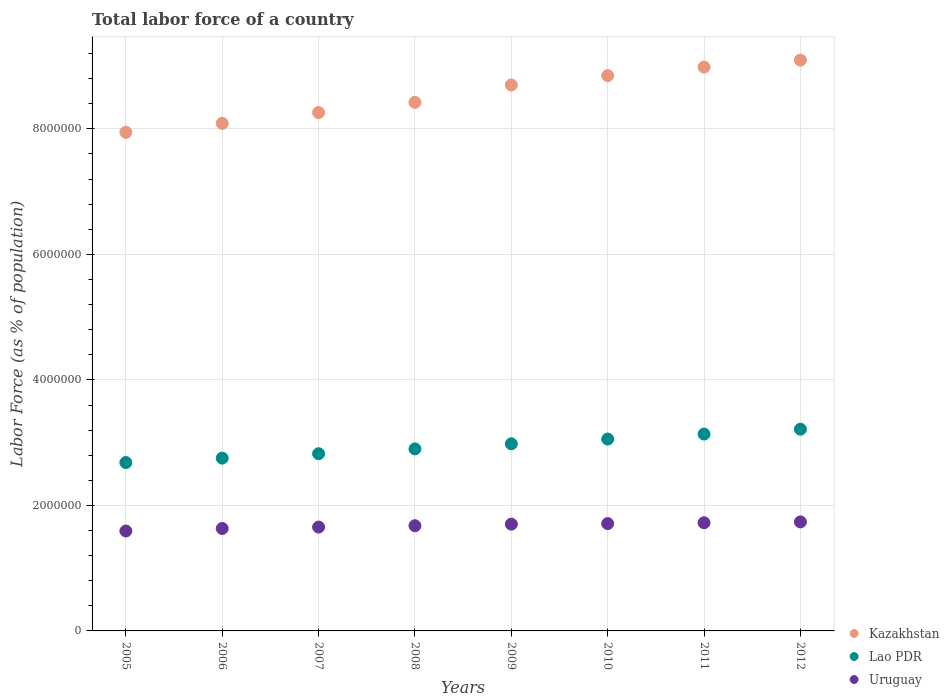Is the number of dotlines equal to the number of legend labels?
Give a very brief answer. Yes. What is the percentage of labor force in Lao PDR in 2012?
Give a very brief answer. 3.21e+06. Across all years, what is the maximum percentage of labor force in Lao PDR?
Your response must be concise. 3.21e+06. Across all years, what is the minimum percentage of labor force in Uruguay?
Your response must be concise. 1.59e+06. What is the total percentage of labor force in Kazakhstan in the graph?
Your response must be concise. 6.83e+07. What is the difference between the percentage of labor force in Lao PDR in 2007 and that in 2009?
Keep it short and to the point. -1.58e+05. What is the difference between the percentage of labor force in Uruguay in 2005 and the percentage of labor force in Lao PDR in 2009?
Your answer should be very brief. -1.39e+06. What is the average percentage of labor force in Lao PDR per year?
Provide a short and direct response. 2.94e+06. In the year 2008, what is the difference between the percentage of labor force in Kazakhstan and percentage of labor force in Uruguay?
Your response must be concise. 6.75e+06. What is the ratio of the percentage of labor force in Lao PDR in 2008 to that in 2010?
Your response must be concise. 0.95. Is the percentage of labor force in Uruguay in 2007 less than that in 2012?
Provide a short and direct response. Yes. What is the difference between the highest and the second highest percentage of labor force in Uruguay?
Provide a succinct answer. 1.34e+04. What is the difference between the highest and the lowest percentage of labor force in Lao PDR?
Give a very brief answer. 5.31e+05. In how many years, is the percentage of labor force in Kazakhstan greater than the average percentage of labor force in Kazakhstan taken over all years?
Your response must be concise. 4. Is it the case that in every year, the sum of the percentage of labor force in Kazakhstan and percentage of labor force in Uruguay  is greater than the percentage of labor force in Lao PDR?
Provide a short and direct response. Yes. Is the percentage of labor force in Kazakhstan strictly less than the percentage of labor force in Lao PDR over the years?
Provide a succinct answer. No. How many years are there in the graph?
Keep it short and to the point. 8. Are the values on the major ticks of Y-axis written in scientific E-notation?
Provide a succinct answer. No. What is the title of the graph?
Your answer should be very brief. Total labor force of a country. Does "Guinea-Bissau" appear as one of the legend labels in the graph?
Your answer should be compact. No. What is the label or title of the Y-axis?
Your response must be concise. Labor Force (as % of population). What is the Labor Force (as % of population) of Kazakhstan in 2005?
Give a very brief answer. 7.95e+06. What is the Labor Force (as % of population) in Lao PDR in 2005?
Keep it short and to the point. 2.68e+06. What is the Labor Force (as % of population) in Uruguay in 2005?
Your response must be concise. 1.59e+06. What is the Labor Force (as % of population) in Kazakhstan in 2006?
Offer a terse response. 8.09e+06. What is the Labor Force (as % of population) of Lao PDR in 2006?
Keep it short and to the point. 2.75e+06. What is the Labor Force (as % of population) of Uruguay in 2006?
Your answer should be very brief. 1.63e+06. What is the Labor Force (as % of population) of Kazakhstan in 2007?
Offer a very short reply. 8.26e+06. What is the Labor Force (as % of population) of Lao PDR in 2007?
Your response must be concise. 2.82e+06. What is the Labor Force (as % of population) of Uruguay in 2007?
Make the answer very short. 1.65e+06. What is the Labor Force (as % of population) of Kazakhstan in 2008?
Provide a succinct answer. 8.42e+06. What is the Labor Force (as % of population) in Lao PDR in 2008?
Your response must be concise. 2.90e+06. What is the Labor Force (as % of population) in Uruguay in 2008?
Provide a succinct answer. 1.68e+06. What is the Labor Force (as % of population) of Kazakhstan in 2009?
Your response must be concise. 8.70e+06. What is the Labor Force (as % of population) in Lao PDR in 2009?
Your answer should be compact. 2.98e+06. What is the Labor Force (as % of population) of Uruguay in 2009?
Provide a succinct answer. 1.70e+06. What is the Labor Force (as % of population) in Kazakhstan in 2010?
Offer a very short reply. 8.85e+06. What is the Labor Force (as % of population) in Lao PDR in 2010?
Make the answer very short. 3.06e+06. What is the Labor Force (as % of population) of Uruguay in 2010?
Your answer should be compact. 1.71e+06. What is the Labor Force (as % of population) in Kazakhstan in 2011?
Offer a terse response. 8.98e+06. What is the Labor Force (as % of population) of Lao PDR in 2011?
Your answer should be very brief. 3.14e+06. What is the Labor Force (as % of population) of Uruguay in 2011?
Provide a short and direct response. 1.72e+06. What is the Labor Force (as % of population) in Kazakhstan in 2012?
Your response must be concise. 9.10e+06. What is the Labor Force (as % of population) of Lao PDR in 2012?
Provide a short and direct response. 3.21e+06. What is the Labor Force (as % of population) in Uruguay in 2012?
Provide a short and direct response. 1.74e+06. Across all years, what is the maximum Labor Force (as % of population) in Kazakhstan?
Your response must be concise. 9.10e+06. Across all years, what is the maximum Labor Force (as % of population) of Lao PDR?
Your answer should be compact. 3.21e+06. Across all years, what is the maximum Labor Force (as % of population) of Uruguay?
Give a very brief answer. 1.74e+06. Across all years, what is the minimum Labor Force (as % of population) of Kazakhstan?
Offer a very short reply. 7.95e+06. Across all years, what is the minimum Labor Force (as % of population) in Lao PDR?
Your answer should be very brief. 2.68e+06. Across all years, what is the minimum Labor Force (as % of population) in Uruguay?
Offer a very short reply. 1.59e+06. What is the total Labor Force (as % of population) in Kazakhstan in the graph?
Your response must be concise. 6.83e+07. What is the total Labor Force (as % of population) of Lao PDR in the graph?
Your answer should be compact. 2.36e+07. What is the total Labor Force (as % of population) of Uruguay in the graph?
Keep it short and to the point. 1.34e+07. What is the difference between the Labor Force (as % of population) of Kazakhstan in 2005 and that in 2006?
Offer a very short reply. -1.43e+05. What is the difference between the Labor Force (as % of population) of Lao PDR in 2005 and that in 2006?
Provide a succinct answer. -7.01e+04. What is the difference between the Labor Force (as % of population) of Uruguay in 2005 and that in 2006?
Ensure brevity in your answer.  -4.05e+04. What is the difference between the Labor Force (as % of population) in Kazakhstan in 2005 and that in 2007?
Your answer should be compact. -3.15e+05. What is the difference between the Labor Force (as % of population) in Lao PDR in 2005 and that in 2007?
Make the answer very short. -1.41e+05. What is the difference between the Labor Force (as % of population) in Uruguay in 2005 and that in 2007?
Provide a succinct answer. -6.30e+04. What is the difference between the Labor Force (as % of population) of Kazakhstan in 2005 and that in 2008?
Your response must be concise. -4.77e+05. What is the difference between the Labor Force (as % of population) in Lao PDR in 2005 and that in 2008?
Keep it short and to the point. -2.17e+05. What is the difference between the Labor Force (as % of population) of Uruguay in 2005 and that in 2008?
Your answer should be very brief. -8.47e+04. What is the difference between the Labor Force (as % of population) of Kazakhstan in 2005 and that in 2009?
Provide a short and direct response. -7.55e+05. What is the difference between the Labor Force (as % of population) of Lao PDR in 2005 and that in 2009?
Make the answer very short. -2.99e+05. What is the difference between the Labor Force (as % of population) of Uruguay in 2005 and that in 2009?
Your answer should be very brief. -1.09e+05. What is the difference between the Labor Force (as % of population) of Kazakhstan in 2005 and that in 2010?
Offer a terse response. -9.03e+05. What is the difference between the Labor Force (as % of population) in Lao PDR in 2005 and that in 2010?
Offer a terse response. -3.75e+05. What is the difference between the Labor Force (as % of population) in Uruguay in 2005 and that in 2010?
Provide a succinct answer. -1.18e+05. What is the difference between the Labor Force (as % of population) of Kazakhstan in 2005 and that in 2011?
Keep it short and to the point. -1.04e+06. What is the difference between the Labor Force (as % of population) in Lao PDR in 2005 and that in 2011?
Provide a short and direct response. -4.54e+05. What is the difference between the Labor Force (as % of population) of Uruguay in 2005 and that in 2011?
Keep it short and to the point. -1.32e+05. What is the difference between the Labor Force (as % of population) of Kazakhstan in 2005 and that in 2012?
Your response must be concise. -1.15e+06. What is the difference between the Labor Force (as % of population) of Lao PDR in 2005 and that in 2012?
Your answer should be very brief. -5.31e+05. What is the difference between the Labor Force (as % of population) in Uruguay in 2005 and that in 2012?
Your response must be concise. -1.45e+05. What is the difference between the Labor Force (as % of population) of Kazakhstan in 2006 and that in 2007?
Provide a short and direct response. -1.71e+05. What is the difference between the Labor Force (as % of population) of Lao PDR in 2006 and that in 2007?
Your response must be concise. -7.05e+04. What is the difference between the Labor Force (as % of population) in Uruguay in 2006 and that in 2007?
Offer a terse response. -2.25e+04. What is the difference between the Labor Force (as % of population) of Kazakhstan in 2006 and that in 2008?
Your answer should be compact. -3.34e+05. What is the difference between the Labor Force (as % of population) in Lao PDR in 2006 and that in 2008?
Keep it short and to the point. -1.47e+05. What is the difference between the Labor Force (as % of population) in Uruguay in 2006 and that in 2008?
Provide a succinct answer. -4.42e+04. What is the difference between the Labor Force (as % of population) in Kazakhstan in 2006 and that in 2009?
Keep it short and to the point. -6.11e+05. What is the difference between the Labor Force (as % of population) in Lao PDR in 2006 and that in 2009?
Provide a succinct answer. -2.28e+05. What is the difference between the Labor Force (as % of population) in Uruguay in 2006 and that in 2009?
Offer a terse response. -6.90e+04. What is the difference between the Labor Force (as % of population) in Kazakhstan in 2006 and that in 2010?
Give a very brief answer. -7.60e+05. What is the difference between the Labor Force (as % of population) in Lao PDR in 2006 and that in 2010?
Keep it short and to the point. -3.05e+05. What is the difference between the Labor Force (as % of population) in Uruguay in 2006 and that in 2010?
Provide a short and direct response. -7.79e+04. What is the difference between the Labor Force (as % of population) in Kazakhstan in 2006 and that in 2011?
Your response must be concise. -8.96e+05. What is the difference between the Labor Force (as % of population) in Lao PDR in 2006 and that in 2011?
Offer a terse response. -3.84e+05. What is the difference between the Labor Force (as % of population) of Uruguay in 2006 and that in 2011?
Provide a succinct answer. -9.13e+04. What is the difference between the Labor Force (as % of population) of Kazakhstan in 2006 and that in 2012?
Offer a very short reply. -1.01e+06. What is the difference between the Labor Force (as % of population) of Lao PDR in 2006 and that in 2012?
Your answer should be very brief. -4.61e+05. What is the difference between the Labor Force (as % of population) in Uruguay in 2006 and that in 2012?
Your answer should be compact. -1.05e+05. What is the difference between the Labor Force (as % of population) of Kazakhstan in 2007 and that in 2008?
Your answer should be compact. -1.63e+05. What is the difference between the Labor Force (as % of population) in Lao PDR in 2007 and that in 2008?
Your answer should be very brief. -7.68e+04. What is the difference between the Labor Force (as % of population) in Uruguay in 2007 and that in 2008?
Offer a terse response. -2.17e+04. What is the difference between the Labor Force (as % of population) in Kazakhstan in 2007 and that in 2009?
Your answer should be very brief. -4.40e+05. What is the difference between the Labor Force (as % of population) in Lao PDR in 2007 and that in 2009?
Ensure brevity in your answer.  -1.58e+05. What is the difference between the Labor Force (as % of population) of Uruguay in 2007 and that in 2009?
Provide a short and direct response. -4.65e+04. What is the difference between the Labor Force (as % of population) in Kazakhstan in 2007 and that in 2010?
Ensure brevity in your answer.  -5.88e+05. What is the difference between the Labor Force (as % of population) of Lao PDR in 2007 and that in 2010?
Make the answer very short. -2.34e+05. What is the difference between the Labor Force (as % of population) of Uruguay in 2007 and that in 2010?
Offer a very short reply. -5.54e+04. What is the difference between the Labor Force (as % of population) in Kazakhstan in 2007 and that in 2011?
Provide a succinct answer. -7.25e+05. What is the difference between the Labor Force (as % of population) of Lao PDR in 2007 and that in 2011?
Keep it short and to the point. -3.13e+05. What is the difference between the Labor Force (as % of population) of Uruguay in 2007 and that in 2011?
Your response must be concise. -6.88e+04. What is the difference between the Labor Force (as % of population) of Kazakhstan in 2007 and that in 2012?
Offer a terse response. -8.36e+05. What is the difference between the Labor Force (as % of population) in Lao PDR in 2007 and that in 2012?
Your answer should be compact. -3.91e+05. What is the difference between the Labor Force (as % of population) of Uruguay in 2007 and that in 2012?
Your answer should be compact. -8.22e+04. What is the difference between the Labor Force (as % of population) of Kazakhstan in 2008 and that in 2009?
Offer a terse response. -2.78e+05. What is the difference between the Labor Force (as % of population) in Lao PDR in 2008 and that in 2009?
Offer a very short reply. -8.11e+04. What is the difference between the Labor Force (as % of population) in Uruguay in 2008 and that in 2009?
Ensure brevity in your answer.  -2.48e+04. What is the difference between the Labor Force (as % of population) of Kazakhstan in 2008 and that in 2010?
Your response must be concise. -4.26e+05. What is the difference between the Labor Force (as % of population) of Lao PDR in 2008 and that in 2010?
Give a very brief answer. -1.57e+05. What is the difference between the Labor Force (as % of population) in Uruguay in 2008 and that in 2010?
Give a very brief answer. -3.37e+04. What is the difference between the Labor Force (as % of population) in Kazakhstan in 2008 and that in 2011?
Your response must be concise. -5.62e+05. What is the difference between the Labor Force (as % of population) in Lao PDR in 2008 and that in 2011?
Keep it short and to the point. -2.36e+05. What is the difference between the Labor Force (as % of population) of Uruguay in 2008 and that in 2011?
Ensure brevity in your answer.  -4.71e+04. What is the difference between the Labor Force (as % of population) of Kazakhstan in 2008 and that in 2012?
Your answer should be compact. -6.73e+05. What is the difference between the Labor Force (as % of population) in Lao PDR in 2008 and that in 2012?
Keep it short and to the point. -3.14e+05. What is the difference between the Labor Force (as % of population) of Uruguay in 2008 and that in 2012?
Your answer should be compact. -6.05e+04. What is the difference between the Labor Force (as % of population) in Kazakhstan in 2009 and that in 2010?
Ensure brevity in your answer.  -1.48e+05. What is the difference between the Labor Force (as % of population) in Lao PDR in 2009 and that in 2010?
Provide a short and direct response. -7.61e+04. What is the difference between the Labor Force (as % of population) of Uruguay in 2009 and that in 2010?
Offer a very short reply. -8885. What is the difference between the Labor Force (as % of population) of Kazakhstan in 2009 and that in 2011?
Your answer should be very brief. -2.85e+05. What is the difference between the Labor Force (as % of population) in Lao PDR in 2009 and that in 2011?
Your answer should be compact. -1.55e+05. What is the difference between the Labor Force (as % of population) in Uruguay in 2009 and that in 2011?
Ensure brevity in your answer.  -2.23e+04. What is the difference between the Labor Force (as % of population) in Kazakhstan in 2009 and that in 2012?
Offer a very short reply. -3.96e+05. What is the difference between the Labor Force (as % of population) in Lao PDR in 2009 and that in 2012?
Give a very brief answer. -2.33e+05. What is the difference between the Labor Force (as % of population) in Uruguay in 2009 and that in 2012?
Ensure brevity in your answer.  -3.57e+04. What is the difference between the Labor Force (as % of population) of Kazakhstan in 2010 and that in 2011?
Your answer should be compact. -1.36e+05. What is the difference between the Labor Force (as % of population) of Lao PDR in 2010 and that in 2011?
Your answer should be very brief. -7.91e+04. What is the difference between the Labor Force (as % of population) in Uruguay in 2010 and that in 2011?
Give a very brief answer. -1.34e+04. What is the difference between the Labor Force (as % of population) in Kazakhstan in 2010 and that in 2012?
Provide a short and direct response. -2.47e+05. What is the difference between the Labor Force (as % of population) of Lao PDR in 2010 and that in 2012?
Provide a succinct answer. -1.57e+05. What is the difference between the Labor Force (as % of population) in Uruguay in 2010 and that in 2012?
Ensure brevity in your answer.  -2.68e+04. What is the difference between the Labor Force (as % of population) of Kazakhstan in 2011 and that in 2012?
Provide a succinct answer. -1.11e+05. What is the difference between the Labor Force (as % of population) in Lao PDR in 2011 and that in 2012?
Your answer should be very brief. -7.75e+04. What is the difference between the Labor Force (as % of population) in Uruguay in 2011 and that in 2012?
Make the answer very short. -1.34e+04. What is the difference between the Labor Force (as % of population) of Kazakhstan in 2005 and the Labor Force (as % of population) of Lao PDR in 2006?
Provide a succinct answer. 5.19e+06. What is the difference between the Labor Force (as % of population) of Kazakhstan in 2005 and the Labor Force (as % of population) of Uruguay in 2006?
Provide a short and direct response. 6.31e+06. What is the difference between the Labor Force (as % of population) of Lao PDR in 2005 and the Labor Force (as % of population) of Uruguay in 2006?
Offer a very short reply. 1.05e+06. What is the difference between the Labor Force (as % of population) in Kazakhstan in 2005 and the Labor Force (as % of population) in Lao PDR in 2007?
Offer a terse response. 5.12e+06. What is the difference between the Labor Force (as % of population) of Kazakhstan in 2005 and the Labor Force (as % of population) of Uruguay in 2007?
Your answer should be very brief. 6.29e+06. What is the difference between the Labor Force (as % of population) in Lao PDR in 2005 and the Labor Force (as % of population) in Uruguay in 2007?
Offer a very short reply. 1.03e+06. What is the difference between the Labor Force (as % of population) in Kazakhstan in 2005 and the Labor Force (as % of population) in Lao PDR in 2008?
Keep it short and to the point. 5.04e+06. What is the difference between the Labor Force (as % of population) of Kazakhstan in 2005 and the Labor Force (as % of population) of Uruguay in 2008?
Keep it short and to the point. 6.27e+06. What is the difference between the Labor Force (as % of population) in Lao PDR in 2005 and the Labor Force (as % of population) in Uruguay in 2008?
Ensure brevity in your answer.  1.01e+06. What is the difference between the Labor Force (as % of population) of Kazakhstan in 2005 and the Labor Force (as % of population) of Lao PDR in 2009?
Your answer should be compact. 4.96e+06. What is the difference between the Labor Force (as % of population) in Kazakhstan in 2005 and the Labor Force (as % of population) in Uruguay in 2009?
Keep it short and to the point. 6.24e+06. What is the difference between the Labor Force (as % of population) in Lao PDR in 2005 and the Labor Force (as % of population) in Uruguay in 2009?
Provide a succinct answer. 9.82e+05. What is the difference between the Labor Force (as % of population) in Kazakhstan in 2005 and the Labor Force (as % of population) in Lao PDR in 2010?
Offer a terse response. 4.89e+06. What is the difference between the Labor Force (as % of population) in Kazakhstan in 2005 and the Labor Force (as % of population) in Uruguay in 2010?
Your answer should be compact. 6.24e+06. What is the difference between the Labor Force (as % of population) in Lao PDR in 2005 and the Labor Force (as % of population) in Uruguay in 2010?
Provide a succinct answer. 9.73e+05. What is the difference between the Labor Force (as % of population) in Kazakhstan in 2005 and the Labor Force (as % of population) in Lao PDR in 2011?
Keep it short and to the point. 4.81e+06. What is the difference between the Labor Force (as % of population) in Kazakhstan in 2005 and the Labor Force (as % of population) in Uruguay in 2011?
Your answer should be very brief. 6.22e+06. What is the difference between the Labor Force (as % of population) in Lao PDR in 2005 and the Labor Force (as % of population) in Uruguay in 2011?
Keep it short and to the point. 9.59e+05. What is the difference between the Labor Force (as % of population) in Kazakhstan in 2005 and the Labor Force (as % of population) in Lao PDR in 2012?
Keep it short and to the point. 4.73e+06. What is the difference between the Labor Force (as % of population) in Kazakhstan in 2005 and the Labor Force (as % of population) in Uruguay in 2012?
Provide a short and direct response. 6.21e+06. What is the difference between the Labor Force (as % of population) of Lao PDR in 2005 and the Labor Force (as % of population) of Uruguay in 2012?
Offer a very short reply. 9.46e+05. What is the difference between the Labor Force (as % of population) in Kazakhstan in 2006 and the Labor Force (as % of population) in Lao PDR in 2007?
Keep it short and to the point. 5.26e+06. What is the difference between the Labor Force (as % of population) of Kazakhstan in 2006 and the Labor Force (as % of population) of Uruguay in 2007?
Your answer should be very brief. 6.43e+06. What is the difference between the Labor Force (as % of population) of Lao PDR in 2006 and the Labor Force (as % of population) of Uruguay in 2007?
Provide a short and direct response. 1.10e+06. What is the difference between the Labor Force (as % of population) in Kazakhstan in 2006 and the Labor Force (as % of population) in Lao PDR in 2008?
Provide a short and direct response. 5.19e+06. What is the difference between the Labor Force (as % of population) of Kazakhstan in 2006 and the Labor Force (as % of population) of Uruguay in 2008?
Offer a terse response. 6.41e+06. What is the difference between the Labor Force (as % of population) of Lao PDR in 2006 and the Labor Force (as % of population) of Uruguay in 2008?
Your answer should be compact. 1.08e+06. What is the difference between the Labor Force (as % of population) in Kazakhstan in 2006 and the Labor Force (as % of population) in Lao PDR in 2009?
Keep it short and to the point. 5.11e+06. What is the difference between the Labor Force (as % of population) of Kazakhstan in 2006 and the Labor Force (as % of population) of Uruguay in 2009?
Offer a very short reply. 6.39e+06. What is the difference between the Labor Force (as % of population) of Lao PDR in 2006 and the Labor Force (as % of population) of Uruguay in 2009?
Provide a succinct answer. 1.05e+06. What is the difference between the Labor Force (as % of population) in Kazakhstan in 2006 and the Labor Force (as % of population) in Lao PDR in 2010?
Make the answer very short. 5.03e+06. What is the difference between the Labor Force (as % of population) in Kazakhstan in 2006 and the Labor Force (as % of population) in Uruguay in 2010?
Keep it short and to the point. 6.38e+06. What is the difference between the Labor Force (as % of population) in Lao PDR in 2006 and the Labor Force (as % of population) in Uruguay in 2010?
Offer a terse response. 1.04e+06. What is the difference between the Labor Force (as % of population) of Kazakhstan in 2006 and the Labor Force (as % of population) of Lao PDR in 2011?
Offer a very short reply. 4.95e+06. What is the difference between the Labor Force (as % of population) of Kazakhstan in 2006 and the Labor Force (as % of population) of Uruguay in 2011?
Your response must be concise. 6.37e+06. What is the difference between the Labor Force (as % of population) of Lao PDR in 2006 and the Labor Force (as % of population) of Uruguay in 2011?
Your answer should be compact. 1.03e+06. What is the difference between the Labor Force (as % of population) of Kazakhstan in 2006 and the Labor Force (as % of population) of Lao PDR in 2012?
Offer a terse response. 4.87e+06. What is the difference between the Labor Force (as % of population) in Kazakhstan in 2006 and the Labor Force (as % of population) in Uruguay in 2012?
Provide a short and direct response. 6.35e+06. What is the difference between the Labor Force (as % of population) of Lao PDR in 2006 and the Labor Force (as % of population) of Uruguay in 2012?
Offer a very short reply. 1.02e+06. What is the difference between the Labor Force (as % of population) in Kazakhstan in 2007 and the Labor Force (as % of population) in Lao PDR in 2008?
Give a very brief answer. 5.36e+06. What is the difference between the Labor Force (as % of population) in Kazakhstan in 2007 and the Labor Force (as % of population) in Uruguay in 2008?
Your answer should be compact. 6.58e+06. What is the difference between the Labor Force (as % of population) of Lao PDR in 2007 and the Labor Force (as % of population) of Uruguay in 2008?
Your answer should be compact. 1.15e+06. What is the difference between the Labor Force (as % of population) in Kazakhstan in 2007 and the Labor Force (as % of population) in Lao PDR in 2009?
Your response must be concise. 5.28e+06. What is the difference between the Labor Force (as % of population) in Kazakhstan in 2007 and the Labor Force (as % of population) in Uruguay in 2009?
Offer a very short reply. 6.56e+06. What is the difference between the Labor Force (as % of population) in Lao PDR in 2007 and the Labor Force (as % of population) in Uruguay in 2009?
Make the answer very short. 1.12e+06. What is the difference between the Labor Force (as % of population) of Kazakhstan in 2007 and the Labor Force (as % of population) of Lao PDR in 2010?
Keep it short and to the point. 5.20e+06. What is the difference between the Labor Force (as % of population) of Kazakhstan in 2007 and the Labor Force (as % of population) of Uruguay in 2010?
Keep it short and to the point. 6.55e+06. What is the difference between the Labor Force (as % of population) of Lao PDR in 2007 and the Labor Force (as % of population) of Uruguay in 2010?
Provide a short and direct response. 1.11e+06. What is the difference between the Labor Force (as % of population) in Kazakhstan in 2007 and the Labor Force (as % of population) in Lao PDR in 2011?
Keep it short and to the point. 5.12e+06. What is the difference between the Labor Force (as % of population) in Kazakhstan in 2007 and the Labor Force (as % of population) in Uruguay in 2011?
Keep it short and to the point. 6.54e+06. What is the difference between the Labor Force (as % of population) in Lao PDR in 2007 and the Labor Force (as % of population) in Uruguay in 2011?
Ensure brevity in your answer.  1.10e+06. What is the difference between the Labor Force (as % of population) in Kazakhstan in 2007 and the Labor Force (as % of population) in Lao PDR in 2012?
Your response must be concise. 5.05e+06. What is the difference between the Labor Force (as % of population) of Kazakhstan in 2007 and the Labor Force (as % of population) of Uruguay in 2012?
Ensure brevity in your answer.  6.52e+06. What is the difference between the Labor Force (as % of population) in Lao PDR in 2007 and the Labor Force (as % of population) in Uruguay in 2012?
Make the answer very short. 1.09e+06. What is the difference between the Labor Force (as % of population) in Kazakhstan in 2008 and the Labor Force (as % of population) in Lao PDR in 2009?
Your response must be concise. 5.44e+06. What is the difference between the Labor Force (as % of population) of Kazakhstan in 2008 and the Labor Force (as % of population) of Uruguay in 2009?
Your answer should be very brief. 6.72e+06. What is the difference between the Labor Force (as % of population) of Lao PDR in 2008 and the Labor Force (as % of population) of Uruguay in 2009?
Offer a terse response. 1.20e+06. What is the difference between the Labor Force (as % of population) in Kazakhstan in 2008 and the Labor Force (as % of population) in Lao PDR in 2010?
Offer a very short reply. 5.36e+06. What is the difference between the Labor Force (as % of population) in Kazakhstan in 2008 and the Labor Force (as % of population) in Uruguay in 2010?
Keep it short and to the point. 6.71e+06. What is the difference between the Labor Force (as % of population) in Lao PDR in 2008 and the Labor Force (as % of population) in Uruguay in 2010?
Make the answer very short. 1.19e+06. What is the difference between the Labor Force (as % of population) of Kazakhstan in 2008 and the Labor Force (as % of population) of Lao PDR in 2011?
Your answer should be compact. 5.29e+06. What is the difference between the Labor Force (as % of population) of Kazakhstan in 2008 and the Labor Force (as % of population) of Uruguay in 2011?
Make the answer very short. 6.70e+06. What is the difference between the Labor Force (as % of population) in Lao PDR in 2008 and the Labor Force (as % of population) in Uruguay in 2011?
Your response must be concise. 1.18e+06. What is the difference between the Labor Force (as % of population) in Kazakhstan in 2008 and the Labor Force (as % of population) in Lao PDR in 2012?
Offer a very short reply. 5.21e+06. What is the difference between the Labor Force (as % of population) in Kazakhstan in 2008 and the Labor Force (as % of population) in Uruguay in 2012?
Offer a very short reply. 6.69e+06. What is the difference between the Labor Force (as % of population) of Lao PDR in 2008 and the Labor Force (as % of population) of Uruguay in 2012?
Give a very brief answer. 1.16e+06. What is the difference between the Labor Force (as % of population) of Kazakhstan in 2009 and the Labor Force (as % of population) of Lao PDR in 2010?
Your answer should be very brief. 5.64e+06. What is the difference between the Labor Force (as % of population) of Kazakhstan in 2009 and the Labor Force (as % of population) of Uruguay in 2010?
Provide a succinct answer. 6.99e+06. What is the difference between the Labor Force (as % of population) of Lao PDR in 2009 and the Labor Force (as % of population) of Uruguay in 2010?
Provide a short and direct response. 1.27e+06. What is the difference between the Labor Force (as % of population) of Kazakhstan in 2009 and the Labor Force (as % of population) of Lao PDR in 2011?
Your answer should be very brief. 5.56e+06. What is the difference between the Labor Force (as % of population) in Kazakhstan in 2009 and the Labor Force (as % of population) in Uruguay in 2011?
Make the answer very short. 6.98e+06. What is the difference between the Labor Force (as % of population) in Lao PDR in 2009 and the Labor Force (as % of population) in Uruguay in 2011?
Offer a very short reply. 1.26e+06. What is the difference between the Labor Force (as % of population) of Kazakhstan in 2009 and the Labor Force (as % of population) of Lao PDR in 2012?
Provide a succinct answer. 5.49e+06. What is the difference between the Labor Force (as % of population) of Kazakhstan in 2009 and the Labor Force (as % of population) of Uruguay in 2012?
Give a very brief answer. 6.96e+06. What is the difference between the Labor Force (as % of population) in Lao PDR in 2009 and the Labor Force (as % of population) in Uruguay in 2012?
Make the answer very short. 1.24e+06. What is the difference between the Labor Force (as % of population) of Kazakhstan in 2010 and the Labor Force (as % of population) of Lao PDR in 2011?
Ensure brevity in your answer.  5.71e+06. What is the difference between the Labor Force (as % of population) in Kazakhstan in 2010 and the Labor Force (as % of population) in Uruguay in 2011?
Ensure brevity in your answer.  7.12e+06. What is the difference between the Labor Force (as % of population) of Lao PDR in 2010 and the Labor Force (as % of population) of Uruguay in 2011?
Provide a succinct answer. 1.33e+06. What is the difference between the Labor Force (as % of population) of Kazakhstan in 2010 and the Labor Force (as % of population) of Lao PDR in 2012?
Offer a terse response. 5.63e+06. What is the difference between the Labor Force (as % of population) of Kazakhstan in 2010 and the Labor Force (as % of population) of Uruguay in 2012?
Your answer should be compact. 7.11e+06. What is the difference between the Labor Force (as % of population) of Lao PDR in 2010 and the Labor Force (as % of population) of Uruguay in 2012?
Ensure brevity in your answer.  1.32e+06. What is the difference between the Labor Force (as % of population) in Kazakhstan in 2011 and the Labor Force (as % of population) in Lao PDR in 2012?
Keep it short and to the point. 5.77e+06. What is the difference between the Labor Force (as % of population) of Kazakhstan in 2011 and the Labor Force (as % of population) of Uruguay in 2012?
Your answer should be compact. 7.25e+06. What is the difference between the Labor Force (as % of population) in Lao PDR in 2011 and the Labor Force (as % of population) in Uruguay in 2012?
Offer a terse response. 1.40e+06. What is the average Labor Force (as % of population) in Kazakhstan per year?
Provide a succinct answer. 8.54e+06. What is the average Labor Force (as % of population) in Lao PDR per year?
Ensure brevity in your answer.  2.94e+06. What is the average Labor Force (as % of population) in Uruguay per year?
Offer a very short reply. 1.68e+06. In the year 2005, what is the difference between the Labor Force (as % of population) of Kazakhstan and Labor Force (as % of population) of Lao PDR?
Give a very brief answer. 5.26e+06. In the year 2005, what is the difference between the Labor Force (as % of population) of Kazakhstan and Labor Force (as % of population) of Uruguay?
Ensure brevity in your answer.  6.35e+06. In the year 2005, what is the difference between the Labor Force (as % of population) of Lao PDR and Labor Force (as % of population) of Uruguay?
Give a very brief answer. 1.09e+06. In the year 2006, what is the difference between the Labor Force (as % of population) of Kazakhstan and Labor Force (as % of population) of Lao PDR?
Offer a terse response. 5.34e+06. In the year 2006, what is the difference between the Labor Force (as % of population) in Kazakhstan and Labor Force (as % of population) in Uruguay?
Keep it short and to the point. 6.46e+06. In the year 2006, what is the difference between the Labor Force (as % of population) of Lao PDR and Labor Force (as % of population) of Uruguay?
Make the answer very short. 1.12e+06. In the year 2007, what is the difference between the Labor Force (as % of population) of Kazakhstan and Labor Force (as % of population) of Lao PDR?
Your response must be concise. 5.44e+06. In the year 2007, what is the difference between the Labor Force (as % of population) in Kazakhstan and Labor Force (as % of population) in Uruguay?
Keep it short and to the point. 6.61e+06. In the year 2007, what is the difference between the Labor Force (as % of population) of Lao PDR and Labor Force (as % of population) of Uruguay?
Offer a very short reply. 1.17e+06. In the year 2008, what is the difference between the Labor Force (as % of population) of Kazakhstan and Labor Force (as % of population) of Lao PDR?
Ensure brevity in your answer.  5.52e+06. In the year 2008, what is the difference between the Labor Force (as % of population) of Kazakhstan and Labor Force (as % of population) of Uruguay?
Give a very brief answer. 6.75e+06. In the year 2008, what is the difference between the Labor Force (as % of population) of Lao PDR and Labor Force (as % of population) of Uruguay?
Make the answer very short. 1.22e+06. In the year 2009, what is the difference between the Labor Force (as % of population) of Kazakhstan and Labor Force (as % of population) of Lao PDR?
Offer a terse response. 5.72e+06. In the year 2009, what is the difference between the Labor Force (as % of population) in Kazakhstan and Labor Force (as % of population) in Uruguay?
Provide a succinct answer. 7.00e+06. In the year 2009, what is the difference between the Labor Force (as % of population) in Lao PDR and Labor Force (as % of population) in Uruguay?
Offer a very short reply. 1.28e+06. In the year 2010, what is the difference between the Labor Force (as % of population) of Kazakhstan and Labor Force (as % of population) of Lao PDR?
Your response must be concise. 5.79e+06. In the year 2010, what is the difference between the Labor Force (as % of population) of Kazakhstan and Labor Force (as % of population) of Uruguay?
Provide a succinct answer. 7.14e+06. In the year 2010, what is the difference between the Labor Force (as % of population) of Lao PDR and Labor Force (as % of population) of Uruguay?
Offer a terse response. 1.35e+06. In the year 2011, what is the difference between the Labor Force (as % of population) of Kazakhstan and Labor Force (as % of population) of Lao PDR?
Keep it short and to the point. 5.85e+06. In the year 2011, what is the difference between the Labor Force (as % of population) of Kazakhstan and Labor Force (as % of population) of Uruguay?
Offer a very short reply. 7.26e+06. In the year 2011, what is the difference between the Labor Force (as % of population) in Lao PDR and Labor Force (as % of population) in Uruguay?
Ensure brevity in your answer.  1.41e+06. In the year 2012, what is the difference between the Labor Force (as % of population) in Kazakhstan and Labor Force (as % of population) in Lao PDR?
Offer a very short reply. 5.88e+06. In the year 2012, what is the difference between the Labor Force (as % of population) in Kazakhstan and Labor Force (as % of population) in Uruguay?
Your answer should be very brief. 7.36e+06. In the year 2012, what is the difference between the Labor Force (as % of population) of Lao PDR and Labor Force (as % of population) of Uruguay?
Make the answer very short. 1.48e+06. What is the ratio of the Labor Force (as % of population) of Kazakhstan in 2005 to that in 2006?
Keep it short and to the point. 0.98. What is the ratio of the Labor Force (as % of population) in Lao PDR in 2005 to that in 2006?
Keep it short and to the point. 0.97. What is the ratio of the Labor Force (as % of population) in Uruguay in 2005 to that in 2006?
Make the answer very short. 0.98. What is the ratio of the Labor Force (as % of population) of Kazakhstan in 2005 to that in 2007?
Offer a very short reply. 0.96. What is the ratio of the Labor Force (as % of population) of Lao PDR in 2005 to that in 2007?
Offer a very short reply. 0.95. What is the ratio of the Labor Force (as % of population) of Uruguay in 2005 to that in 2007?
Ensure brevity in your answer.  0.96. What is the ratio of the Labor Force (as % of population) in Kazakhstan in 2005 to that in 2008?
Your answer should be very brief. 0.94. What is the ratio of the Labor Force (as % of population) of Lao PDR in 2005 to that in 2008?
Keep it short and to the point. 0.93. What is the ratio of the Labor Force (as % of population) of Uruguay in 2005 to that in 2008?
Make the answer very short. 0.95. What is the ratio of the Labor Force (as % of population) in Kazakhstan in 2005 to that in 2009?
Give a very brief answer. 0.91. What is the ratio of the Labor Force (as % of population) in Lao PDR in 2005 to that in 2009?
Give a very brief answer. 0.9. What is the ratio of the Labor Force (as % of population) of Uruguay in 2005 to that in 2009?
Provide a succinct answer. 0.94. What is the ratio of the Labor Force (as % of population) in Kazakhstan in 2005 to that in 2010?
Offer a very short reply. 0.9. What is the ratio of the Labor Force (as % of population) of Lao PDR in 2005 to that in 2010?
Ensure brevity in your answer.  0.88. What is the ratio of the Labor Force (as % of population) of Uruguay in 2005 to that in 2010?
Make the answer very short. 0.93. What is the ratio of the Labor Force (as % of population) of Kazakhstan in 2005 to that in 2011?
Your response must be concise. 0.88. What is the ratio of the Labor Force (as % of population) in Lao PDR in 2005 to that in 2011?
Your answer should be very brief. 0.86. What is the ratio of the Labor Force (as % of population) in Uruguay in 2005 to that in 2011?
Your answer should be compact. 0.92. What is the ratio of the Labor Force (as % of population) in Kazakhstan in 2005 to that in 2012?
Keep it short and to the point. 0.87. What is the ratio of the Labor Force (as % of population) of Lao PDR in 2005 to that in 2012?
Keep it short and to the point. 0.83. What is the ratio of the Labor Force (as % of population) of Uruguay in 2005 to that in 2012?
Make the answer very short. 0.92. What is the ratio of the Labor Force (as % of population) of Kazakhstan in 2006 to that in 2007?
Make the answer very short. 0.98. What is the ratio of the Labor Force (as % of population) of Lao PDR in 2006 to that in 2007?
Offer a terse response. 0.97. What is the ratio of the Labor Force (as % of population) in Uruguay in 2006 to that in 2007?
Offer a terse response. 0.99. What is the ratio of the Labor Force (as % of population) of Kazakhstan in 2006 to that in 2008?
Keep it short and to the point. 0.96. What is the ratio of the Labor Force (as % of population) of Lao PDR in 2006 to that in 2008?
Provide a short and direct response. 0.95. What is the ratio of the Labor Force (as % of population) in Uruguay in 2006 to that in 2008?
Offer a terse response. 0.97. What is the ratio of the Labor Force (as % of population) of Kazakhstan in 2006 to that in 2009?
Your answer should be very brief. 0.93. What is the ratio of the Labor Force (as % of population) of Lao PDR in 2006 to that in 2009?
Your response must be concise. 0.92. What is the ratio of the Labor Force (as % of population) of Uruguay in 2006 to that in 2009?
Offer a terse response. 0.96. What is the ratio of the Labor Force (as % of population) of Kazakhstan in 2006 to that in 2010?
Give a very brief answer. 0.91. What is the ratio of the Labor Force (as % of population) of Lao PDR in 2006 to that in 2010?
Keep it short and to the point. 0.9. What is the ratio of the Labor Force (as % of population) in Uruguay in 2006 to that in 2010?
Give a very brief answer. 0.95. What is the ratio of the Labor Force (as % of population) in Kazakhstan in 2006 to that in 2011?
Ensure brevity in your answer.  0.9. What is the ratio of the Labor Force (as % of population) of Lao PDR in 2006 to that in 2011?
Ensure brevity in your answer.  0.88. What is the ratio of the Labor Force (as % of population) of Uruguay in 2006 to that in 2011?
Provide a succinct answer. 0.95. What is the ratio of the Labor Force (as % of population) of Kazakhstan in 2006 to that in 2012?
Offer a terse response. 0.89. What is the ratio of the Labor Force (as % of population) in Lao PDR in 2006 to that in 2012?
Provide a short and direct response. 0.86. What is the ratio of the Labor Force (as % of population) of Uruguay in 2006 to that in 2012?
Ensure brevity in your answer.  0.94. What is the ratio of the Labor Force (as % of population) in Kazakhstan in 2007 to that in 2008?
Provide a succinct answer. 0.98. What is the ratio of the Labor Force (as % of population) in Lao PDR in 2007 to that in 2008?
Provide a succinct answer. 0.97. What is the ratio of the Labor Force (as % of population) in Uruguay in 2007 to that in 2008?
Ensure brevity in your answer.  0.99. What is the ratio of the Labor Force (as % of population) in Kazakhstan in 2007 to that in 2009?
Provide a short and direct response. 0.95. What is the ratio of the Labor Force (as % of population) in Lao PDR in 2007 to that in 2009?
Your answer should be compact. 0.95. What is the ratio of the Labor Force (as % of population) in Uruguay in 2007 to that in 2009?
Give a very brief answer. 0.97. What is the ratio of the Labor Force (as % of population) in Kazakhstan in 2007 to that in 2010?
Provide a short and direct response. 0.93. What is the ratio of the Labor Force (as % of population) in Lao PDR in 2007 to that in 2010?
Your answer should be very brief. 0.92. What is the ratio of the Labor Force (as % of population) in Uruguay in 2007 to that in 2010?
Ensure brevity in your answer.  0.97. What is the ratio of the Labor Force (as % of population) in Kazakhstan in 2007 to that in 2011?
Provide a short and direct response. 0.92. What is the ratio of the Labor Force (as % of population) in Lao PDR in 2007 to that in 2011?
Give a very brief answer. 0.9. What is the ratio of the Labor Force (as % of population) in Uruguay in 2007 to that in 2011?
Offer a terse response. 0.96. What is the ratio of the Labor Force (as % of population) in Kazakhstan in 2007 to that in 2012?
Make the answer very short. 0.91. What is the ratio of the Labor Force (as % of population) in Lao PDR in 2007 to that in 2012?
Keep it short and to the point. 0.88. What is the ratio of the Labor Force (as % of population) of Uruguay in 2007 to that in 2012?
Offer a terse response. 0.95. What is the ratio of the Labor Force (as % of population) in Kazakhstan in 2008 to that in 2009?
Offer a very short reply. 0.97. What is the ratio of the Labor Force (as % of population) of Lao PDR in 2008 to that in 2009?
Your answer should be compact. 0.97. What is the ratio of the Labor Force (as % of population) of Uruguay in 2008 to that in 2009?
Offer a terse response. 0.99. What is the ratio of the Labor Force (as % of population) in Kazakhstan in 2008 to that in 2010?
Keep it short and to the point. 0.95. What is the ratio of the Labor Force (as % of population) of Lao PDR in 2008 to that in 2010?
Keep it short and to the point. 0.95. What is the ratio of the Labor Force (as % of population) in Uruguay in 2008 to that in 2010?
Offer a very short reply. 0.98. What is the ratio of the Labor Force (as % of population) in Kazakhstan in 2008 to that in 2011?
Offer a terse response. 0.94. What is the ratio of the Labor Force (as % of population) of Lao PDR in 2008 to that in 2011?
Keep it short and to the point. 0.92. What is the ratio of the Labor Force (as % of population) of Uruguay in 2008 to that in 2011?
Provide a short and direct response. 0.97. What is the ratio of the Labor Force (as % of population) of Kazakhstan in 2008 to that in 2012?
Your answer should be very brief. 0.93. What is the ratio of the Labor Force (as % of population) of Lao PDR in 2008 to that in 2012?
Offer a very short reply. 0.9. What is the ratio of the Labor Force (as % of population) of Uruguay in 2008 to that in 2012?
Keep it short and to the point. 0.97. What is the ratio of the Labor Force (as % of population) of Kazakhstan in 2009 to that in 2010?
Ensure brevity in your answer.  0.98. What is the ratio of the Labor Force (as % of population) in Lao PDR in 2009 to that in 2010?
Offer a very short reply. 0.98. What is the ratio of the Labor Force (as % of population) in Kazakhstan in 2009 to that in 2011?
Your answer should be very brief. 0.97. What is the ratio of the Labor Force (as % of population) of Lao PDR in 2009 to that in 2011?
Provide a short and direct response. 0.95. What is the ratio of the Labor Force (as % of population) in Kazakhstan in 2009 to that in 2012?
Provide a succinct answer. 0.96. What is the ratio of the Labor Force (as % of population) in Lao PDR in 2009 to that in 2012?
Provide a succinct answer. 0.93. What is the ratio of the Labor Force (as % of population) of Uruguay in 2009 to that in 2012?
Keep it short and to the point. 0.98. What is the ratio of the Labor Force (as % of population) in Lao PDR in 2010 to that in 2011?
Offer a terse response. 0.97. What is the ratio of the Labor Force (as % of population) in Kazakhstan in 2010 to that in 2012?
Provide a succinct answer. 0.97. What is the ratio of the Labor Force (as % of population) in Lao PDR in 2010 to that in 2012?
Your response must be concise. 0.95. What is the ratio of the Labor Force (as % of population) in Uruguay in 2010 to that in 2012?
Give a very brief answer. 0.98. What is the ratio of the Labor Force (as % of population) in Kazakhstan in 2011 to that in 2012?
Provide a succinct answer. 0.99. What is the ratio of the Labor Force (as % of population) in Lao PDR in 2011 to that in 2012?
Your answer should be very brief. 0.98. What is the difference between the highest and the second highest Labor Force (as % of population) of Kazakhstan?
Keep it short and to the point. 1.11e+05. What is the difference between the highest and the second highest Labor Force (as % of population) in Lao PDR?
Give a very brief answer. 7.75e+04. What is the difference between the highest and the second highest Labor Force (as % of population) of Uruguay?
Ensure brevity in your answer.  1.34e+04. What is the difference between the highest and the lowest Labor Force (as % of population) in Kazakhstan?
Give a very brief answer. 1.15e+06. What is the difference between the highest and the lowest Labor Force (as % of population) in Lao PDR?
Your answer should be very brief. 5.31e+05. What is the difference between the highest and the lowest Labor Force (as % of population) in Uruguay?
Ensure brevity in your answer.  1.45e+05. 